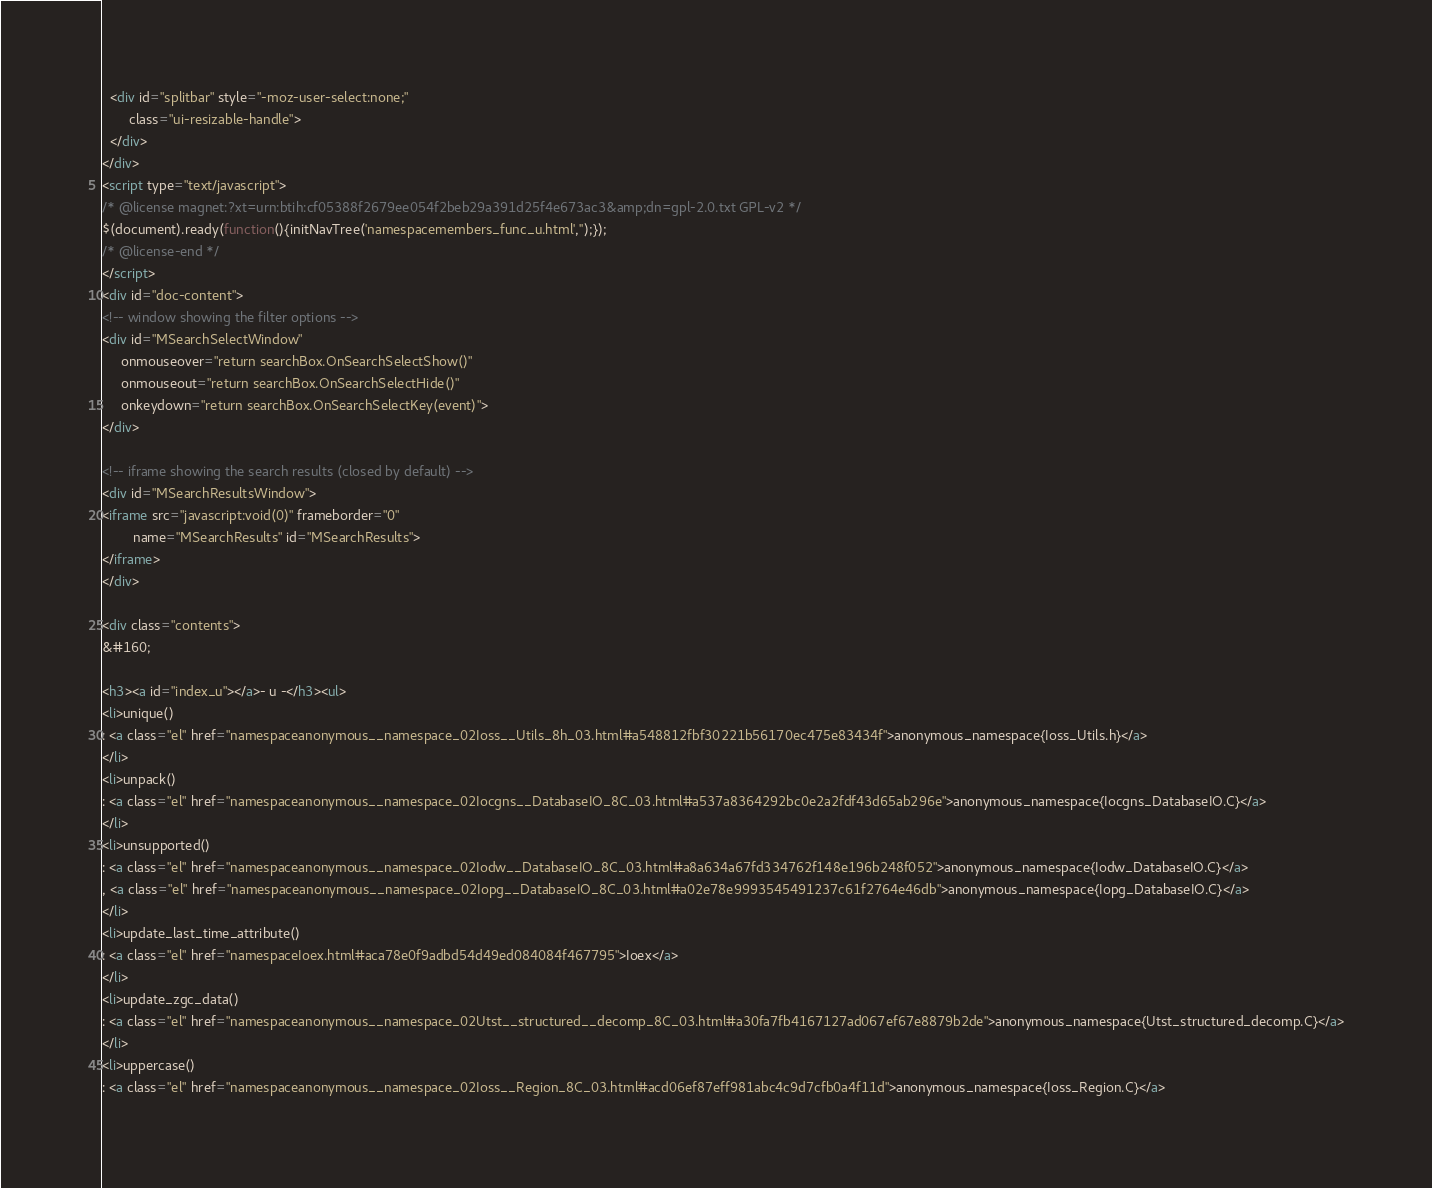<code> <loc_0><loc_0><loc_500><loc_500><_HTML_>  <div id="splitbar" style="-moz-user-select:none;" 
       class="ui-resizable-handle">
  </div>
</div>
<script type="text/javascript">
/* @license magnet:?xt=urn:btih:cf05388f2679ee054f2beb29a391d25f4e673ac3&amp;dn=gpl-2.0.txt GPL-v2 */
$(document).ready(function(){initNavTree('namespacemembers_func_u.html','');});
/* @license-end */
</script>
<div id="doc-content">
<!-- window showing the filter options -->
<div id="MSearchSelectWindow"
     onmouseover="return searchBox.OnSearchSelectShow()"
     onmouseout="return searchBox.OnSearchSelectHide()"
     onkeydown="return searchBox.OnSearchSelectKey(event)">
</div>

<!-- iframe showing the search results (closed by default) -->
<div id="MSearchResultsWindow">
<iframe src="javascript:void(0)" frameborder="0" 
        name="MSearchResults" id="MSearchResults">
</iframe>
</div>

<div class="contents">
&#160;

<h3><a id="index_u"></a>- u -</h3><ul>
<li>unique()
: <a class="el" href="namespaceanonymous__namespace_02Ioss__Utils_8h_03.html#a548812fbf30221b56170ec475e83434f">anonymous_namespace{Ioss_Utils.h}</a>
</li>
<li>unpack()
: <a class="el" href="namespaceanonymous__namespace_02Iocgns__DatabaseIO_8C_03.html#a537a8364292bc0e2a2fdf43d65ab296e">anonymous_namespace{Iocgns_DatabaseIO.C}</a>
</li>
<li>unsupported()
: <a class="el" href="namespaceanonymous__namespace_02Iodw__DatabaseIO_8C_03.html#a8a634a67fd334762f148e196b248f052">anonymous_namespace{Iodw_DatabaseIO.C}</a>
, <a class="el" href="namespaceanonymous__namespace_02Iopg__DatabaseIO_8C_03.html#a02e78e9993545491237c61f2764e46db">anonymous_namespace{Iopg_DatabaseIO.C}</a>
</li>
<li>update_last_time_attribute()
: <a class="el" href="namespaceIoex.html#aca78e0f9adbd54d49ed084084f467795">Ioex</a>
</li>
<li>update_zgc_data()
: <a class="el" href="namespaceanonymous__namespace_02Utst__structured__decomp_8C_03.html#a30fa7fb4167127ad067ef67e8879b2de">anonymous_namespace{Utst_structured_decomp.C}</a>
</li>
<li>uppercase()
: <a class="el" href="namespaceanonymous__namespace_02Ioss__Region_8C_03.html#acd06ef87eff981abc4c9d7cfb0a4f11d">anonymous_namespace{Ioss_Region.C}</a></code> 